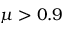<formula> <loc_0><loc_0><loc_500><loc_500>\mu > 0 . 9</formula> 